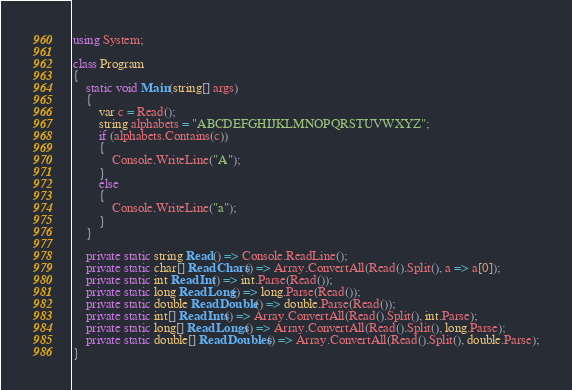Convert code to text. <code><loc_0><loc_0><loc_500><loc_500><_C#_>using System;

class Program
{
    static void Main(string[] args)
    {
        var c = Read();
        string alphabets = "ABCDEFGHIJKLMNOPQRSTUVWXYZ";
        if (alphabets.Contains(c))
        {
            Console.WriteLine("A");
        }
        else
        {
            Console.WriteLine("a");
        }
    }

    private static string Read() => Console.ReadLine();
    private static char[] ReadChars() => Array.ConvertAll(Read().Split(), a => a[0]);
    private static int ReadInt() => int.Parse(Read());
    private static long ReadLong() => long.Parse(Read());
    private static double ReadDouble() => double.Parse(Read());
    private static int[] ReadInts() => Array.ConvertAll(Read().Split(), int.Parse);
    private static long[] ReadLongs() => Array.ConvertAll(Read().Split(), long.Parse);
    private static double[] ReadDoubles() => Array.ConvertAll(Read().Split(), double.Parse);
}</code> 